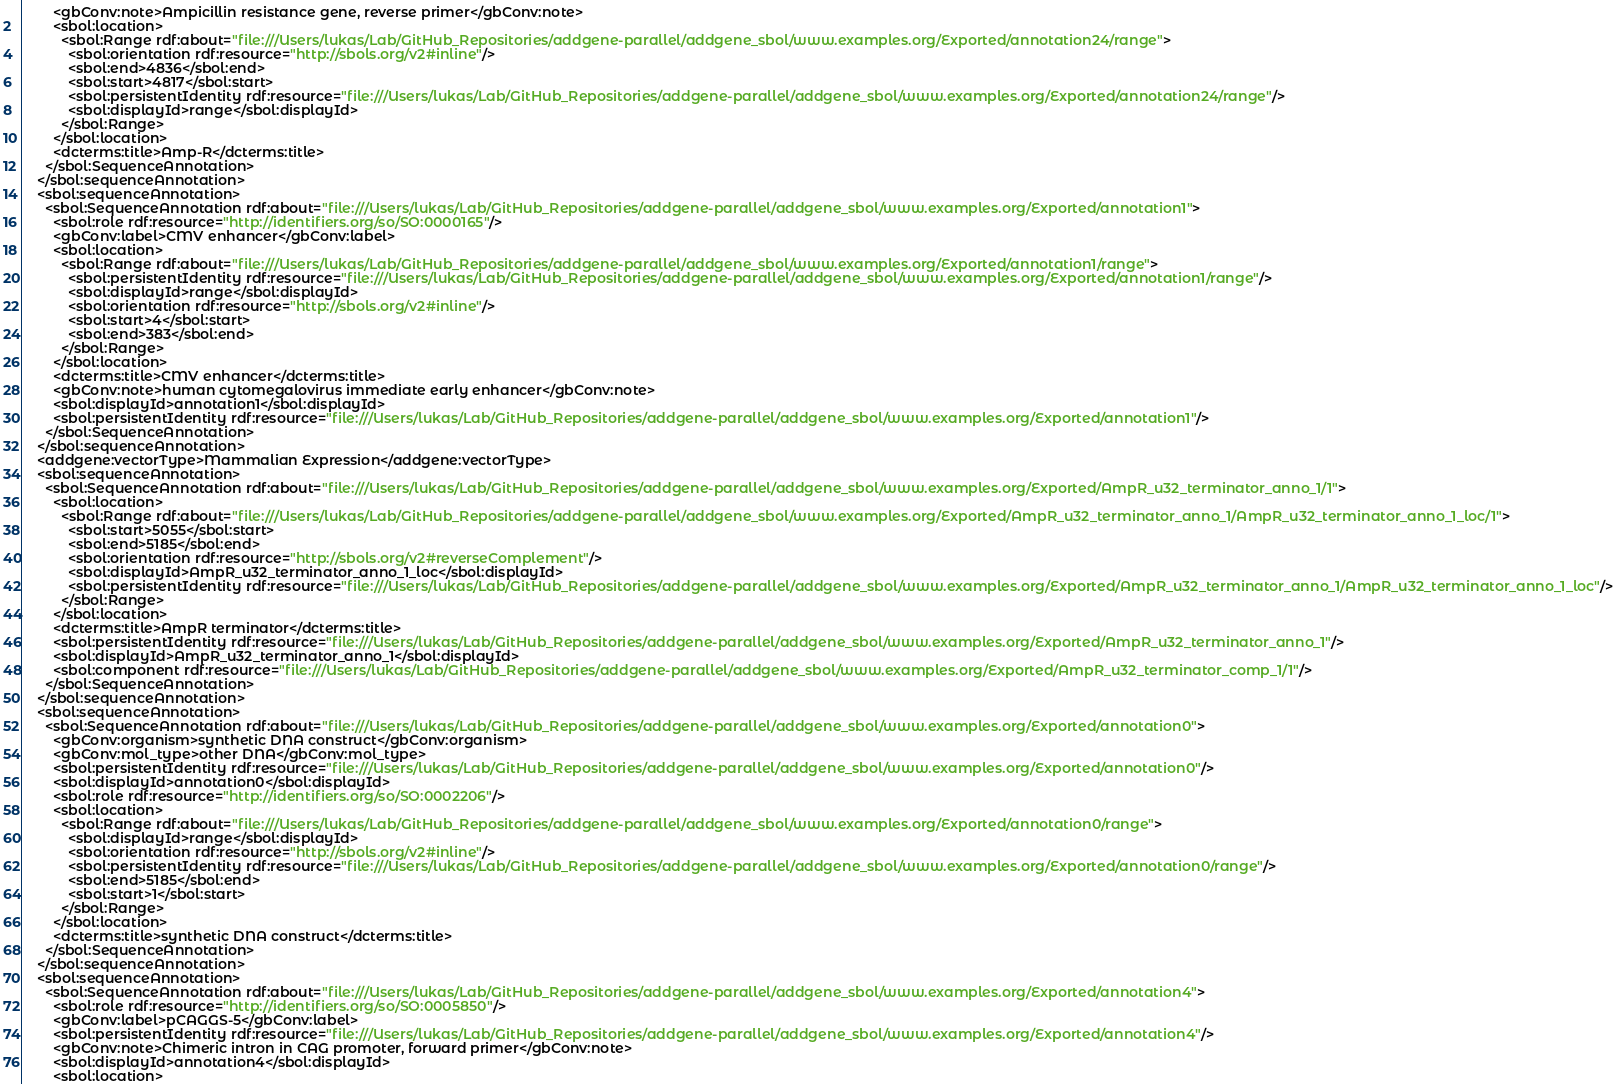<code> <loc_0><loc_0><loc_500><loc_500><_XML_>        <gbConv:note>Ampicillin resistance gene, reverse primer</gbConv:note>
        <sbol:location>
          <sbol:Range rdf:about="file:///Users/lukas/Lab/GitHub_Repositories/addgene-parallel/addgene_sbol/www.examples.org/Exported/annotation24/range">
            <sbol:orientation rdf:resource="http://sbols.org/v2#inline"/>
            <sbol:end>4836</sbol:end>
            <sbol:start>4817</sbol:start>
            <sbol:persistentIdentity rdf:resource="file:///Users/lukas/Lab/GitHub_Repositories/addgene-parallel/addgene_sbol/www.examples.org/Exported/annotation24/range"/>
            <sbol:displayId>range</sbol:displayId>
          </sbol:Range>
        </sbol:location>
        <dcterms:title>Amp-R</dcterms:title>
      </sbol:SequenceAnnotation>
    </sbol:sequenceAnnotation>
    <sbol:sequenceAnnotation>
      <sbol:SequenceAnnotation rdf:about="file:///Users/lukas/Lab/GitHub_Repositories/addgene-parallel/addgene_sbol/www.examples.org/Exported/annotation1">
        <sbol:role rdf:resource="http://identifiers.org/so/SO:0000165"/>
        <gbConv:label>CMV enhancer</gbConv:label>
        <sbol:location>
          <sbol:Range rdf:about="file:///Users/lukas/Lab/GitHub_Repositories/addgene-parallel/addgene_sbol/www.examples.org/Exported/annotation1/range">
            <sbol:persistentIdentity rdf:resource="file:///Users/lukas/Lab/GitHub_Repositories/addgene-parallel/addgene_sbol/www.examples.org/Exported/annotation1/range"/>
            <sbol:displayId>range</sbol:displayId>
            <sbol:orientation rdf:resource="http://sbols.org/v2#inline"/>
            <sbol:start>4</sbol:start>
            <sbol:end>383</sbol:end>
          </sbol:Range>
        </sbol:location>
        <dcterms:title>CMV enhancer</dcterms:title>
        <gbConv:note>human cytomegalovirus immediate early enhancer</gbConv:note>
        <sbol:displayId>annotation1</sbol:displayId>
        <sbol:persistentIdentity rdf:resource="file:///Users/lukas/Lab/GitHub_Repositories/addgene-parallel/addgene_sbol/www.examples.org/Exported/annotation1"/>
      </sbol:SequenceAnnotation>
    </sbol:sequenceAnnotation>
    <addgene:vectorType>Mammalian Expression</addgene:vectorType>
    <sbol:sequenceAnnotation>
      <sbol:SequenceAnnotation rdf:about="file:///Users/lukas/Lab/GitHub_Repositories/addgene-parallel/addgene_sbol/www.examples.org/Exported/AmpR_u32_terminator_anno_1/1">
        <sbol:location>
          <sbol:Range rdf:about="file:///Users/lukas/Lab/GitHub_Repositories/addgene-parallel/addgene_sbol/www.examples.org/Exported/AmpR_u32_terminator_anno_1/AmpR_u32_terminator_anno_1_loc/1">
            <sbol:start>5055</sbol:start>
            <sbol:end>5185</sbol:end>
            <sbol:orientation rdf:resource="http://sbols.org/v2#reverseComplement"/>
            <sbol:displayId>AmpR_u32_terminator_anno_1_loc</sbol:displayId>
            <sbol:persistentIdentity rdf:resource="file:///Users/lukas/Lab/GitHub_Repositories/addgene-parallel/addgene_sbol/www.examples.org/Exported/AmpR_u32_terminator_anno_1/AmpR_u32_terminator_anno_1_loc"/>
          </sbol:Range>
        </sbol:location>
        <dcterms:title>AmpR terminator</dcterms:title>
        <sbol:persistentIdentity rdf:resource="file:///Users/lukas/Lab/GitHub_Repositories/addgene-parallel/addgene_sbol/www.examples.org/Exported/AmpR_u32_terminator_anno_1"/>
        <sbol:displayId>AmpR_u32_terminator_anno_1</sbol:displayId>
        <sbol:component rdf:resource="file:///Users/lukas/Lab/GitHub_Repositories/addgene-parallel/addgene_sbol/www.examples.org/Exported/AmpR_u32_terminator_comp_1/1"/>
      </sbol:SequenceAnnotation>
    </sbol:sequenceAnnotation>
    <sbol:sequenceAnnotation>
      <sbol:SequenceAnnotation rdf:about="file:///Users/lukas/Lab/GitHub_Repositories/addgene-parallel/addgene_sbol/www.examples.org/Exported/annotation0">
        <gbConv:organism>synthetic DNA construct</gbConv:organism>
        <gbConv:mol_type>other DNA</gbConv:mol_type>
        <sbol:persistentIdentity rdf:resource="file:///Users/lukas/Lab/GitHub_Repositories/addgene-parallel/addgene_sbol/www.examples.org/Exported/annotation0"/>
        <sbol:displayId>annotation0</sbol:displayId>
        <sbol:role rdf:resource="http://identifiers.org/so/SO:0002206"/>
        <sbol:location>
          <sbol:Range rdf:about="file:///Users/lukas/Lab/GitHub_Repositories/addgene-parallel/addgene_sbol/www.examples.org/Exported/annotation0/range">
            <sbol:displayId>range</sbol:displayId>
            <sbol:orientation rdf:resource="http://sbols.org/v2#inline"/>
            <sbol:persistentIdentity rdf:resource="file:///Users/lukas/Lab/GitHub_Repositories/addgene-parallel/addgene_sbol/www.examples.org/Exported/annotation0/range"/>
            <sbol:end>5185</sbol:end>
            <sbol:start>1</sbol:start>
          </sbol:Range>
        </sbol:location>
        <dcterms:title>synthetic DNA construct</dcterms:title>
      </sbol:SequenceAnnotation>
    </sbol:sequenceAnnotation>
    <sbol:sequenceAnnotation>
      <sbol:SequenceAnnotation rdf:about="file:///Users/lukas/Lab/GitHub_Repositories/addgene-parallel/addgene_sbol/www.examples.org/Exported/annotation4">
        <sbol:role rdf:resource="http://identifiers.org/so/SO:0005850"/>
        <gbConv:label>pCAGGS-5</gbConv:label>
        <sbol:persistentIdentity rdf:resource="file:///Users/lukas/Lab/GitHub_Repositories/addgene-parallel/addgene_sbol/www.examples.org/Exported/annotation4"/>
        <gbConv:note>Chimeric intron in CAG promoter, forward primer</gbConv:note>
        <sbol:displayId>annotation4</sbol:displayId>
        <sbol:location></code> 